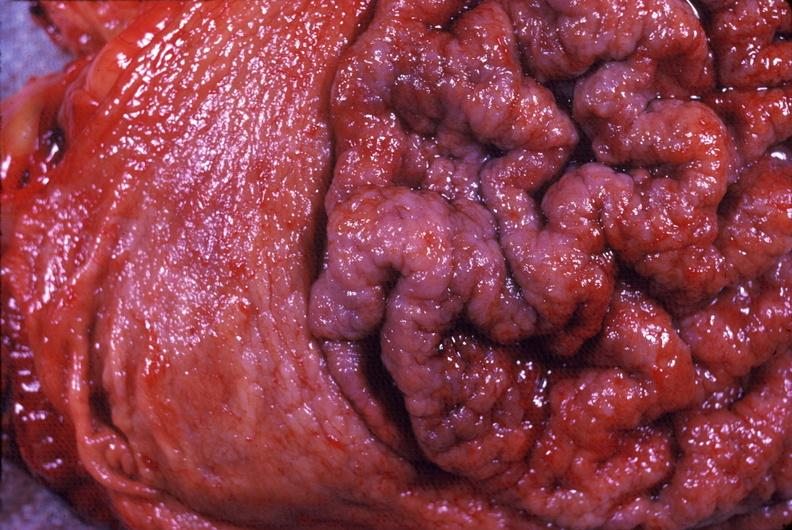what is present?
Answer the question using a single word or phrase. Gastrointestinal 